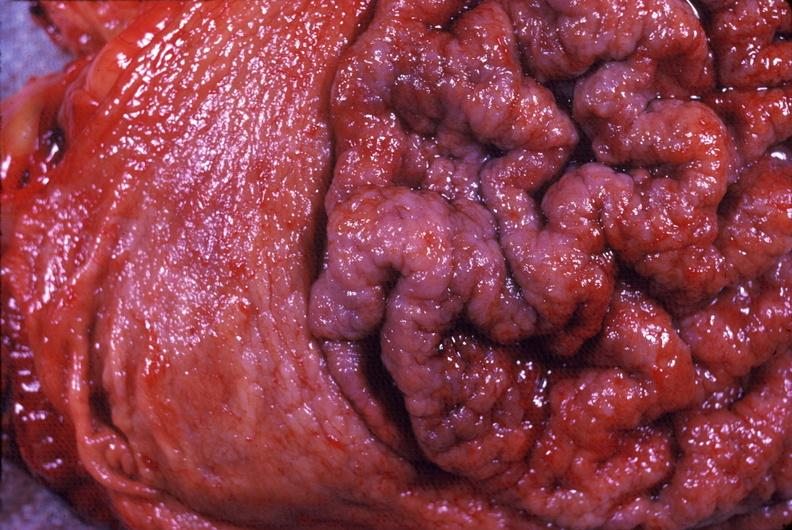what is present?
Answer the question using a single word or phrase. Gastrointestinal 